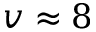<formula> <loc_0><loc_0><loc_500><loc_500>v \approx 8</formula> 